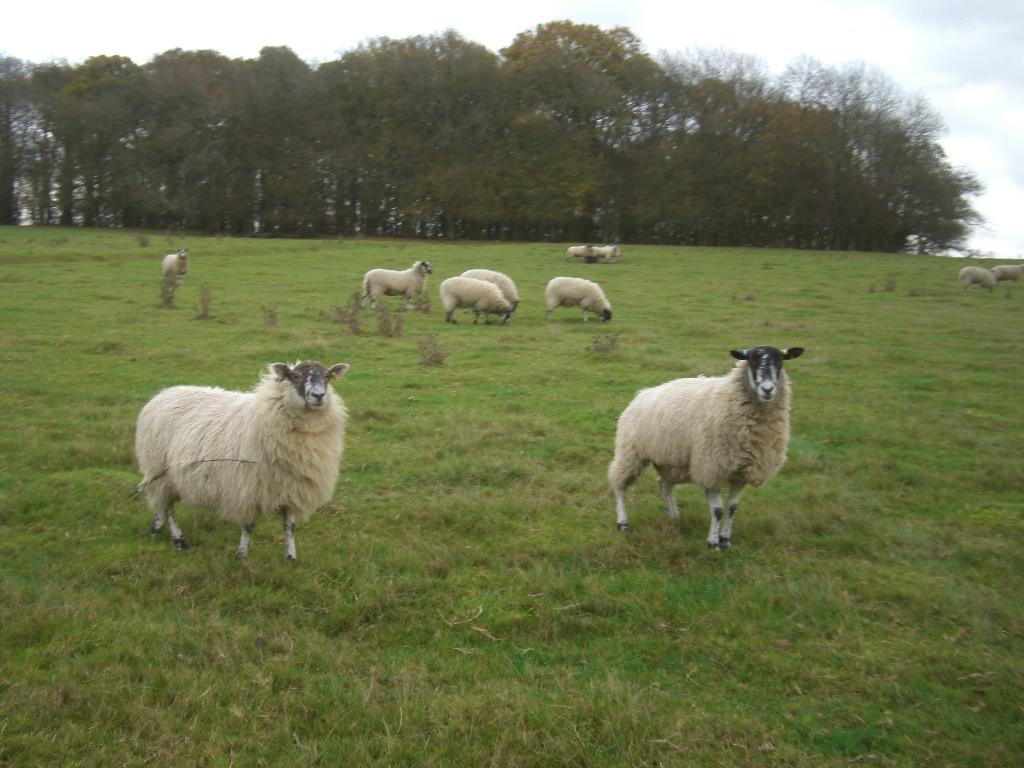What animals are present in the image? There is a group of sheep in the image. Where are the sheep located? The sheep are on a grass field. What can be seen in the background of the image? There are plants and a group of trees in the background of the image. What is visible at the top of the image? The sky is visible at the top of the image. What is the rate at which the sheep are controlling the grass field in the image? The image does not provide information about the rate at which the sheep are controlling the grass field or any control over the grass field. The sheep are simply grazing on the grass. 